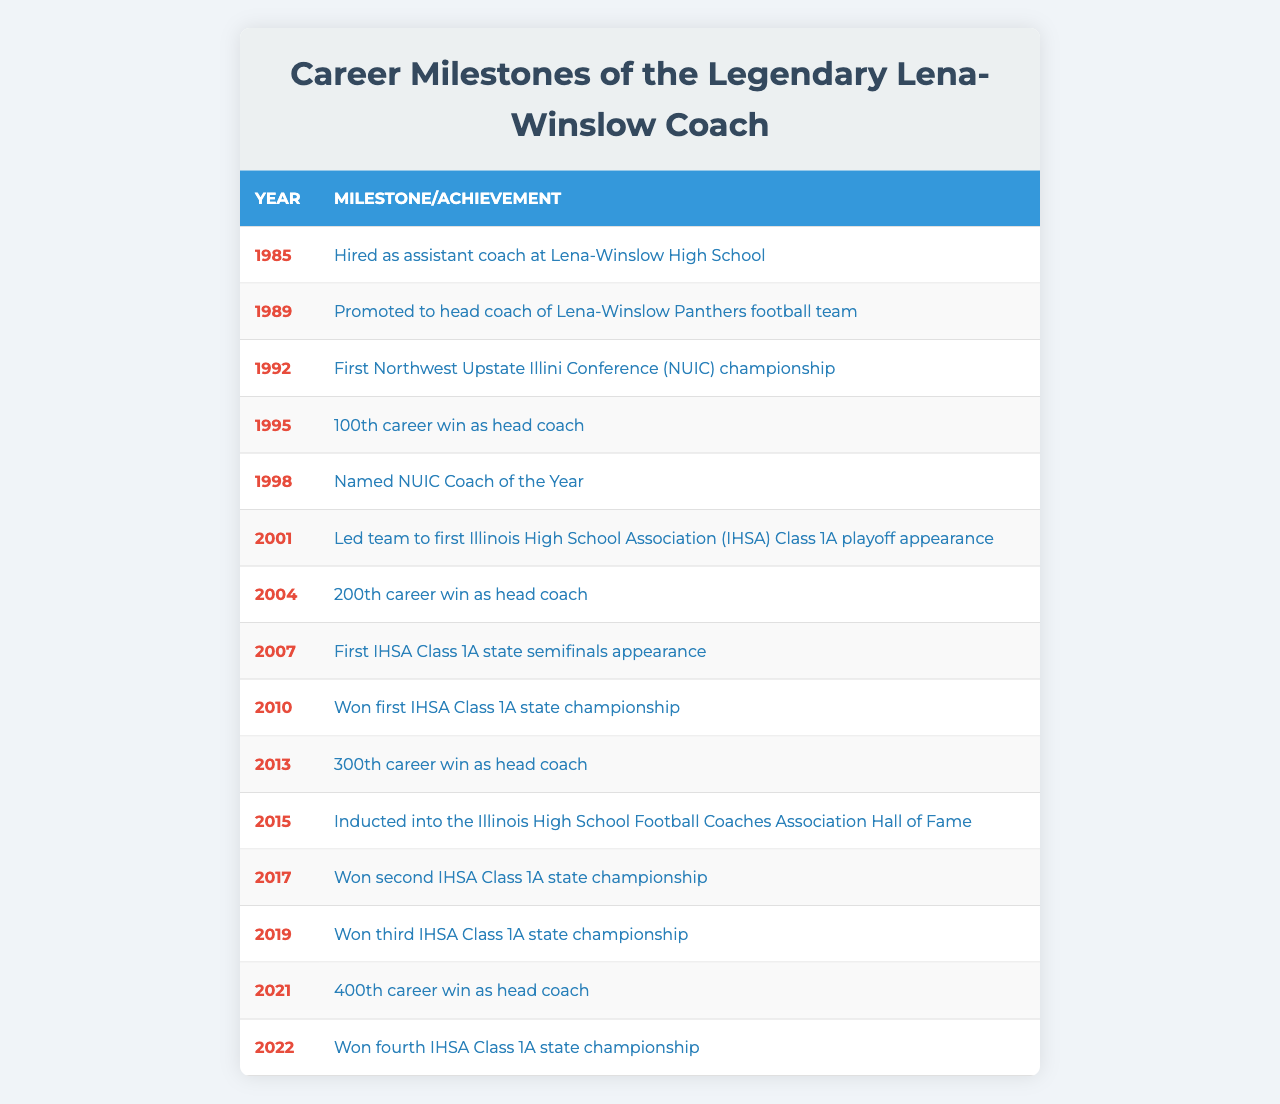What year did the coach achieve his first career milestone? The first milestone listed in the table is in 1985 when he was hired as an assistant coach.
Answer: 1985 Which year marks the 100th career win as head coach? According to the table, the 100th career win occurred in 1995.
Answer: 1995 How many state championships did the coach win by 2022? The table shows four state championships won by 2022: in 2010, 2017, 2019, and 2022.
Answer: Four What was the difference in years between the first and fourth state championships? The first state championship was in 2010 and the fourth was in 2022. Therefore, the difference is 2022 - 2010 = 12 years.
Answer: 12 Did the coach achieve 300 career wins before he was inducted into the Hall of Fame? The table indicates that he achieved his 300th career win in 2013 and was inducted into the Hall of Fame in 2015, so yes, he did.
Answer: Yes Which achievement occurred immediately after the coach's 200th career win? The 200th career win occurred in 2004, and the following achievement listed is the first state semifinals appearance in 2007.
Answer: First state semifinals appearance in 2007 What percentage of the achievements listed are related to state championships? There are seven achievements related to state championships out of 15 total achievements listed, so the percentage is (7/15) * 100 = 46.67%.
Answer: Approximately 47% In which year did the coach lead his team to the first playoff appearance? The table states that the first playoff appearance was in 2001.
Answer: 2001 How many years passed between the coach's first championship and the Hall of Fame induction? The first championship was won in 2010 and the Hall of Fame induction was in 2015, which is 5 years apart.
Answer: 5 years Was there a year when the coach achieved more than one milestone? The table shows that there are years with multiple milestones, such as 2010, which includes the first state championship and the 300th career win.
Answer: Yes 